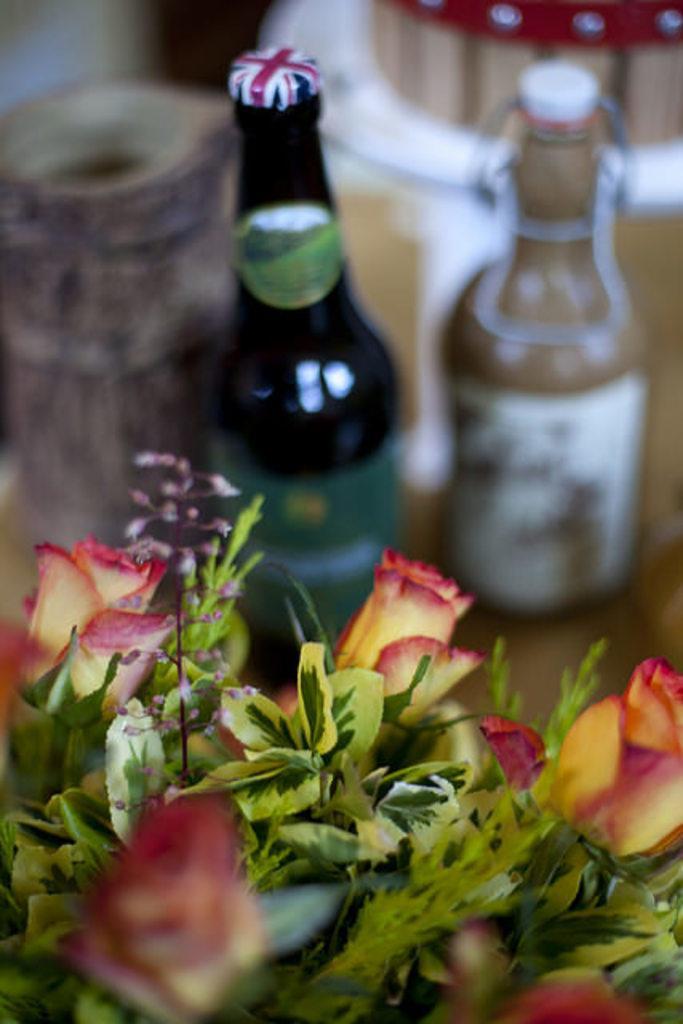Can you describe this image briefly? In this image in the middle there are two bottles. At the bottom there is a flower vase. 